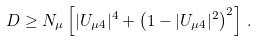<formula> <loc_0><loc_0><loc_500><loc_500>D \geq N _ { \mu } \left [ | U _ { \mu 4 } | ^ { 4 } + \left ( 1 - | U _ { \mu 4 } | ^ { 2 } \right ) ^ { 2 } \right ] \, .</formula> 